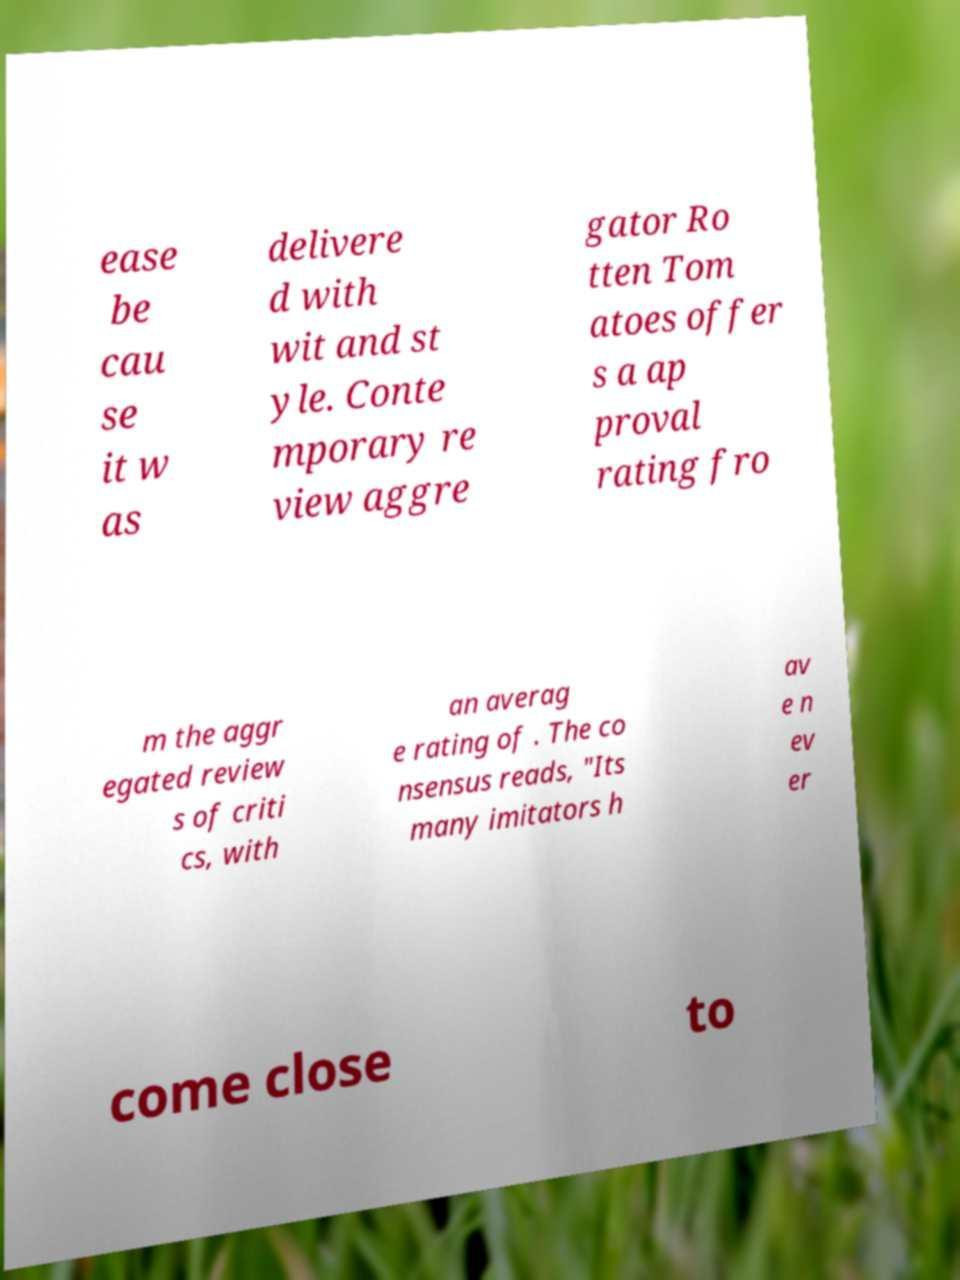I need the written content from this picture converted into text. Can you do that? ease be cau se it w as delivere d with wit and st yle. Conte mporary re view aggre gator Ro tten Tom atoes offer s a ap proval rating fro m the aggr egated review s of criti cs, with an averag e rating of . The co nsensus reads, "Its many imitators h av e n ev er come close to 